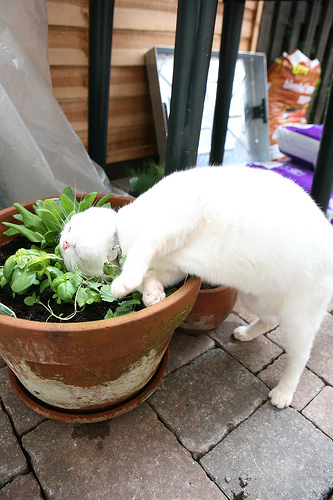What is the color of the cat on the sidewalk? The cat on the sidewalk is white in color. 